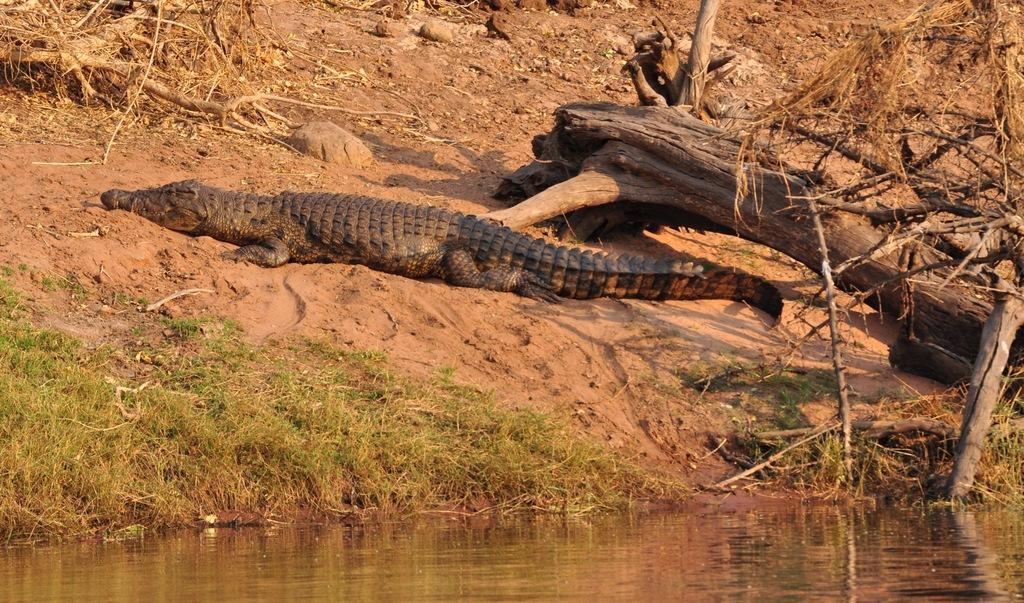What is the primary element visible in the image? There is water in the image. What animal can be seen above the water level? There is a crocodile above the water level in the image. What type of vegetation is present in the image? There are woods and grass on the ground in the image. How many slaves can be seen in the image? There are no slaves present in the image. Is there a spy observing the crocodile in the image? There is no indication of a spy in the image. 